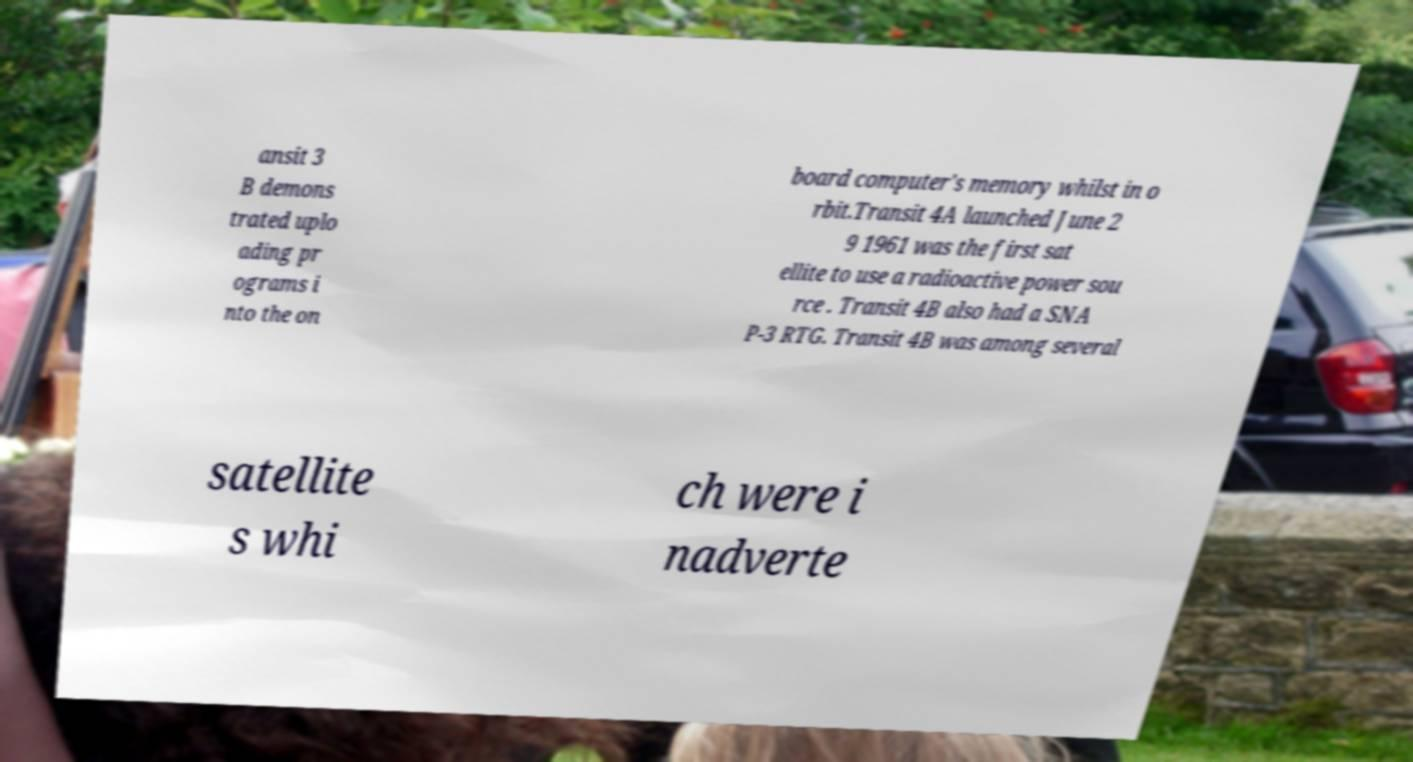Could you extract and type out the text from this image? ansit 3 B demons trated uplo ading pr ograms i nto the on board computer's memory whilst in o rbit.Transit 4A launched June 2 9 1961 was the first sat ellite to use a radioactive power sou rce . Transit 4B also had a SNA P-3 RTG. Transit 4B was among several satellite s whi ch were i nadverte 